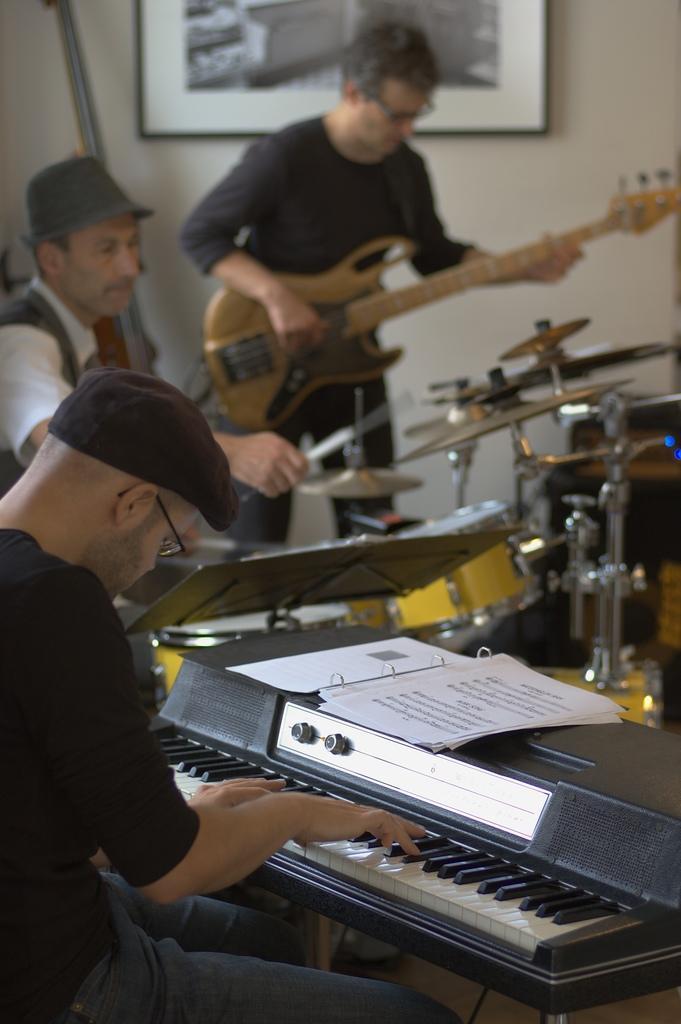In one or two sentences, can you explain what this image depicts? In this picture there are three members playing a different musical instruments in front of them. Two of them were caps. One of the guy is standing. In the background there is a photo frame attached to the wall. 